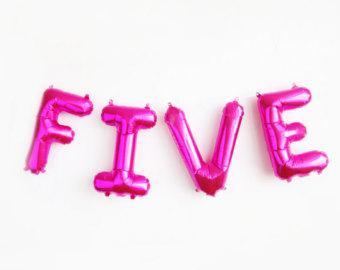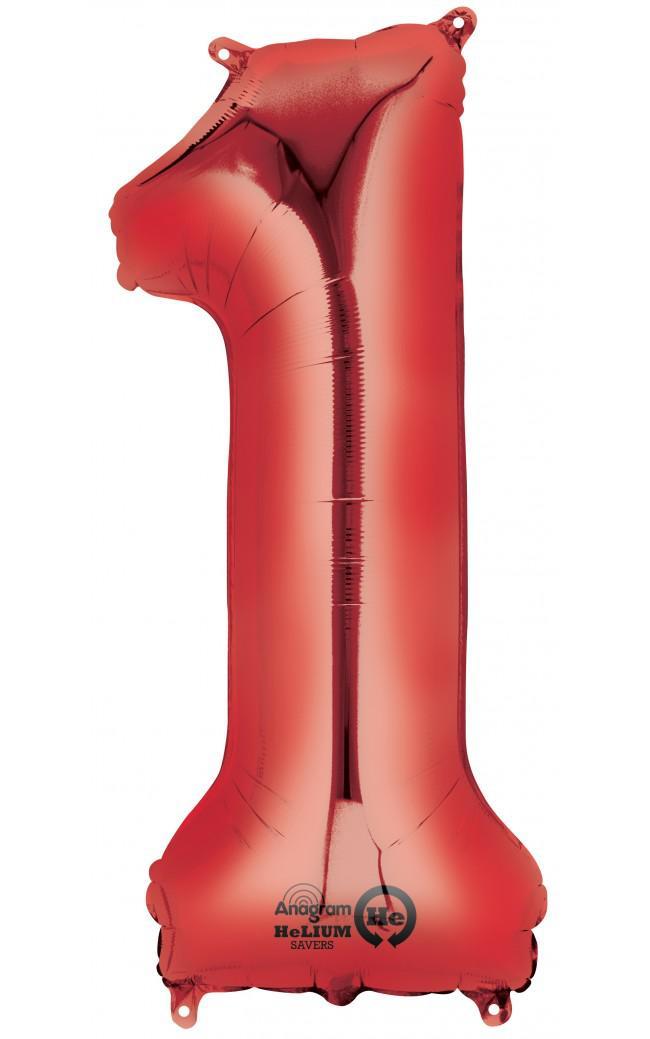The first image is the image on the left, the second image is the image on the right. For the images displayed, is the sentence "At least one balloon is shaped like a number." factually correct? Answer yes or no. Yes. The first image is the image on the left, the second image is the image on the right. Analyze the images presented: Is the assertion "One image shows a balloon that is in the shape of a number" valid? Answer yes or no. Yes. 